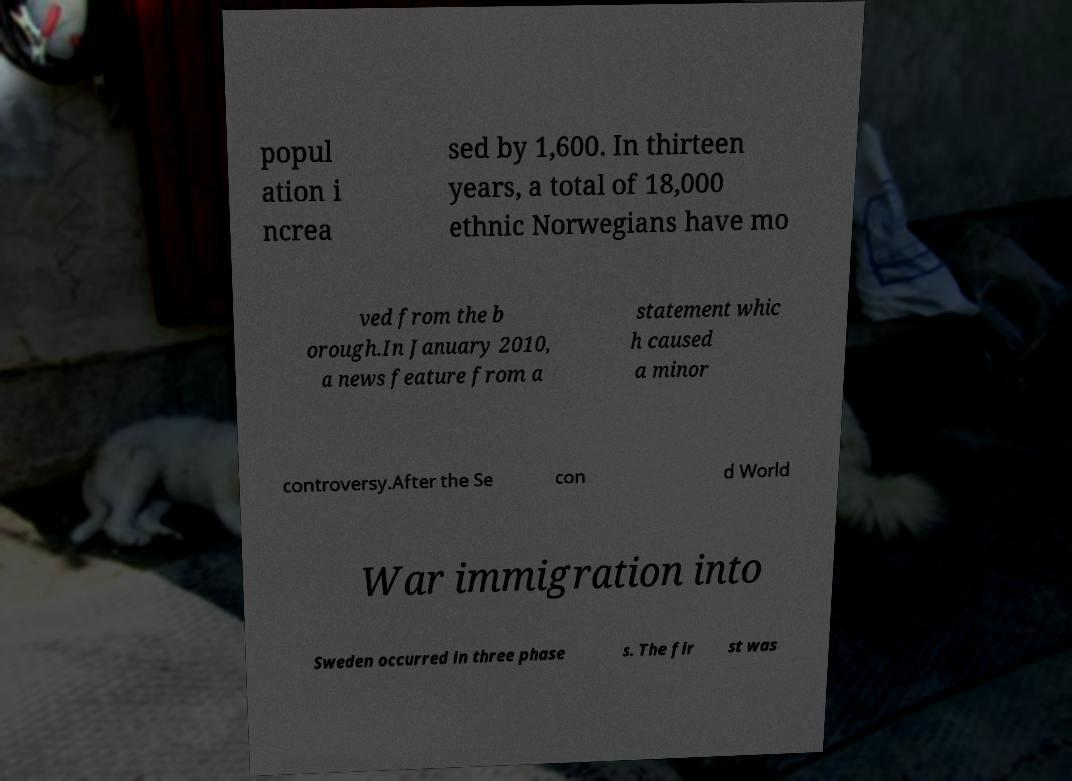There's text embedded in this image that I need extracted. Can you transcribe it verbatim? popul ation i ncrea sed by 1,600. In thirteen years, a total of 18,000 ethnic Norwegians have mo ved from the b orough.In January 2010, a news feature from a statement whic h caused a minor controversy.After the Se con d World War immigration into Sweden occurred in three phase s. The fir st was 